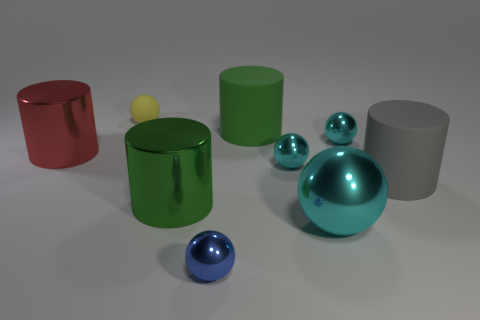Are there fewer cyan metal spheres than tiny blue metallic objects?
Your response must be concise. No. Is there a rubber sphere in front of the tiny cyan shiny object behind the shiny thing that is left of the matte sphere?
Make the answer very short. No. There is a small metallic thing in front of the large gray cylinder; does it have the same shape as the big cyan metallic thing?
Give a very brief answer. Yes. Is the number of big shiny cylinders in front of the big green metallic object greater than the number of big green matte cylinders?
Your response must be concise. No. There is a small sphere that is right of the large cyan metallic thing; is it the same color as the small matte thing?
Make the answer very short. No. Is there any other thing that is the same color as the big shiny ball?
Your answer should be very brief. Yes. The small ball that is in front of the green object in front of the large green cylinder right of the tiny blue metallic ball is what color?
Keep it short and to the point. Blue. Is the red metallic cylinder the same size as the green matte thing?
Provide a succinct answer. Yes. How many yellow things have the same size as the red shiny cylinder?
Provide a succinct answer. 0. Is the material of the large green cylinder in front of the big gray thing the same as the big object left of the tiny rubber ball?
Your answer should be very brief. Yes. 